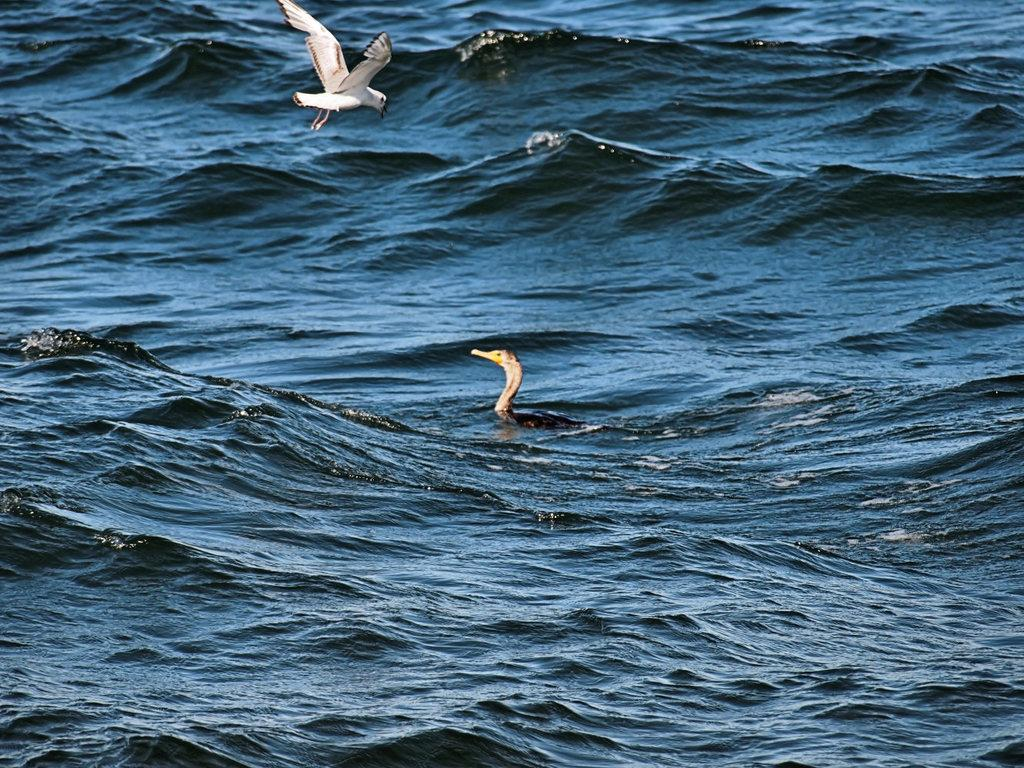What type of animal is in the water in the image? There is a duck in the water in the image. What is happening in the sky above the water? There is a bird flying over the water in the image. What language do the giants speak in the image? There are no giants present in the image, so it is not possible to determine what language they might speak. 